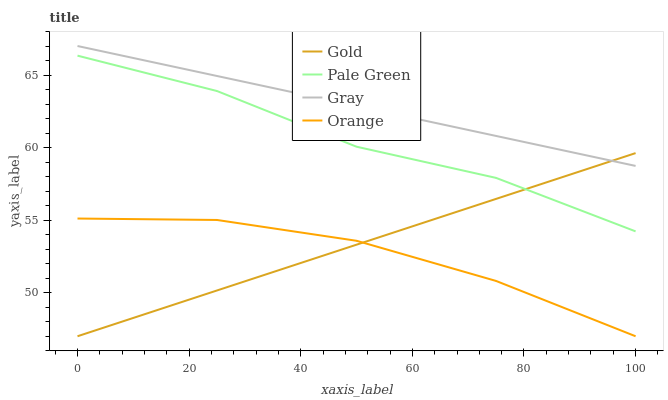Does Orange have the minimum area under the curve?
Answer yes or no. Yes. Does Gray have the maximum area under the curve?
Answer yes or no. Yes. Does Pale Green have the minimum area under the curve?
Answer yes or no. No. Does Pale Green have the maximum area under the curve?
Answer yes or no. No. Is Gold the smoothest?
Answer yes or no. Yes. Is Pale Green the roughest?
Answer yes or no. Yes. Is Gray the smoothest?
Answer yes or no. No. Is Gray the roughest?
Answer yes or no. No. Does Orange have the lowest value?
Answer yes or no. Yes. Does Pale Green have the lowest value?
Answer yes or no. No. Does Gray have the highest value?
Answer yes or no. Yes. Does Pale Green have the highest value?
Answer yes or no. No. Is Pale Green less than Gray?
Answer yes or no. Yes. Is Gray greater than Pale Green?
Answer yes or no. Yes. Does Gold intersect Orange?
Answer yes or no. Yes. Is Gold less than Orange?
Answer yes or no. No. Is Gold greater than Orange?
Answer yes or no. No. Does Pale Green intersect Gray?
Answer yes or no. No. 